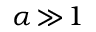<formula> <loc_0><loc_0><loc_500><loc_500>\alpha \, \gg \, 1</formula> 